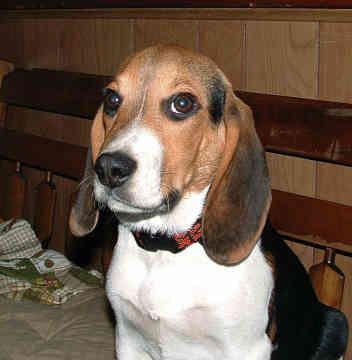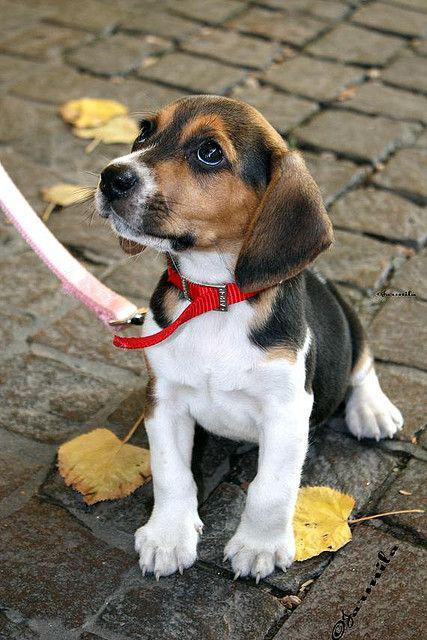The first image is the image on the left, the second image is the image on the right. Evaluate the accuracy of this statement regarding the images: "A dog in one of the images is wearing something on top of its head.". Is it true? Answer yes or no. No. The first image is the image on the left, the second image is the image on the right. For the images displayed, is the sentence "One image contains one dog, which wears a blue collar, and the other image features a dog wearing a costume that includes a hat and something around its neck." factually correct? Answer yes or no. No. 